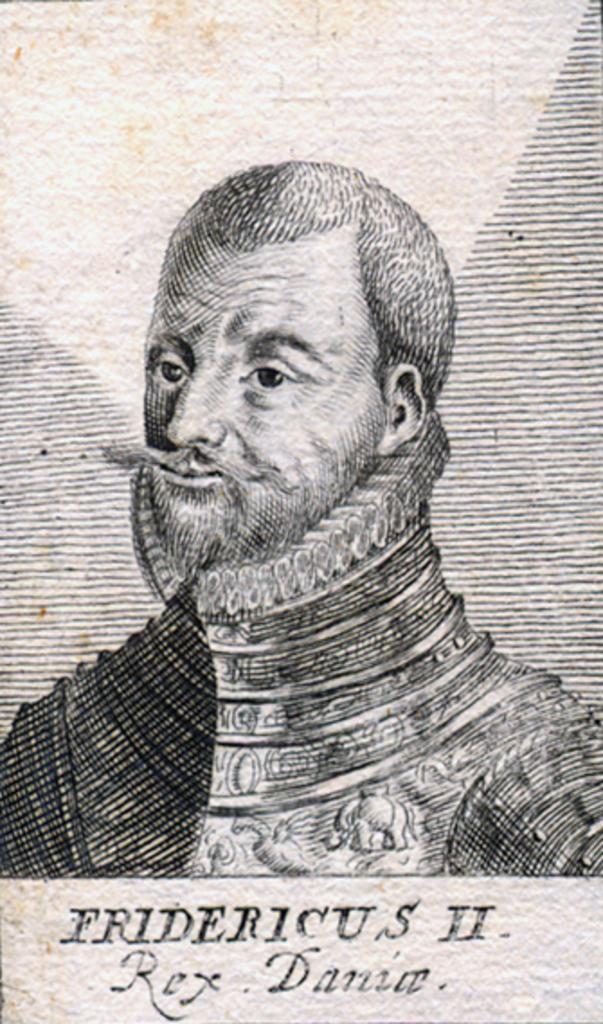Can you describe this image briefly? In this image we can see a drawing of a person wearing a dress with long mustache. 